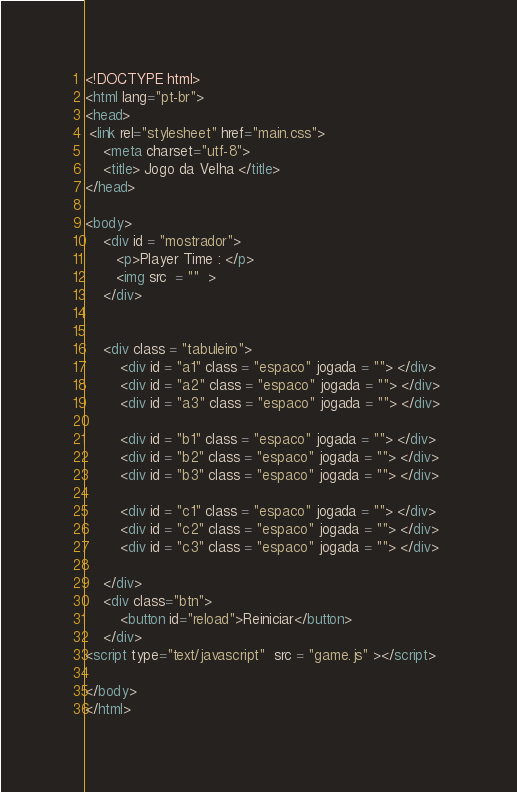<code> <loc_0><loc_0><loc_500><loc_500><_HTML_><!DOCTYPE html>
<html lang="pt-br">
<head>
 <link rel="stylesheet" href="main.css">
    <meta charset="utf-8">
    <title> Jogo da Velha </title>
</head>

<body> 
    <div id = "mostrador"> 
       <p>Player Time : </p> 
       <img src  = ""  >
    </div>
    
    
    <div class = "tabuleiro">   
        <div id = "a1" class = "espaco" jogada = ""> </div>
        <div id = "a2" class = "espaco" jogada = ""> </div>
        <div id = "a3" class = "espaco" jogada = ""> </div>
        
        <div id = "b1" class = "espaco" jogada = ""> </div>
        <div id = "b2" class = "espaco" jogada = ""> </div>
        <div id = "b3" class = "espaco" jogada = ""> </div>
        
        <div id = "c1" class = "espaco" jogada = ""> </div>
        <div id = "c2" class = "espaco" jogada = ""> </div>
        <div id = "c3" class = "espaco" jogada = ""> </div>
        
    </div>
    <div class="btn">
        <button id="reload">Reiniciar</button>
    </div>
<script type="text/javascript"  src = "game.js" ></script>  
    
</body>
</html></code> 